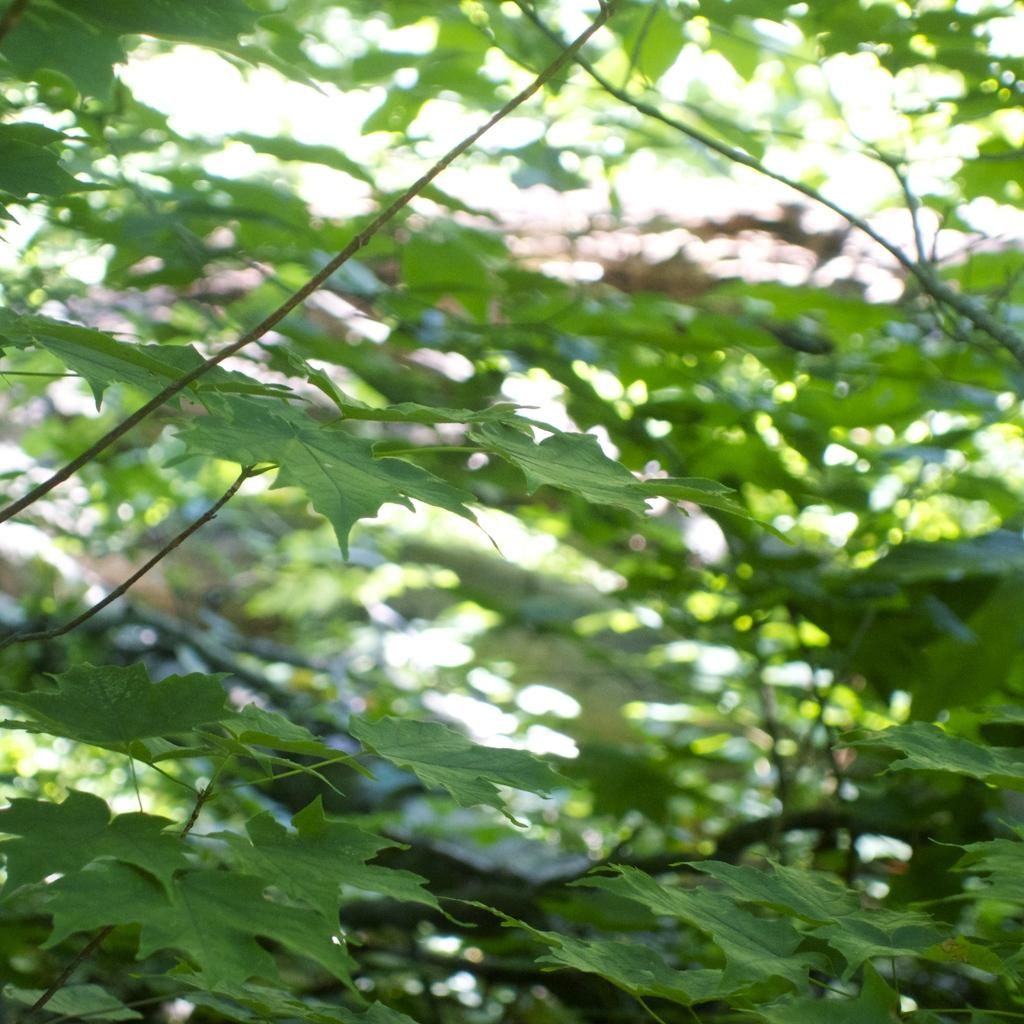What type of vegetation can be seen in the image? There are trees in the image. What is the color of the leaves on the trees? The leaves on the trees have a green color. What nation is responsible for the aftermath of the basin in the image? There is no basin or nation mentioned in the image, so it is not possible to answer that question. 